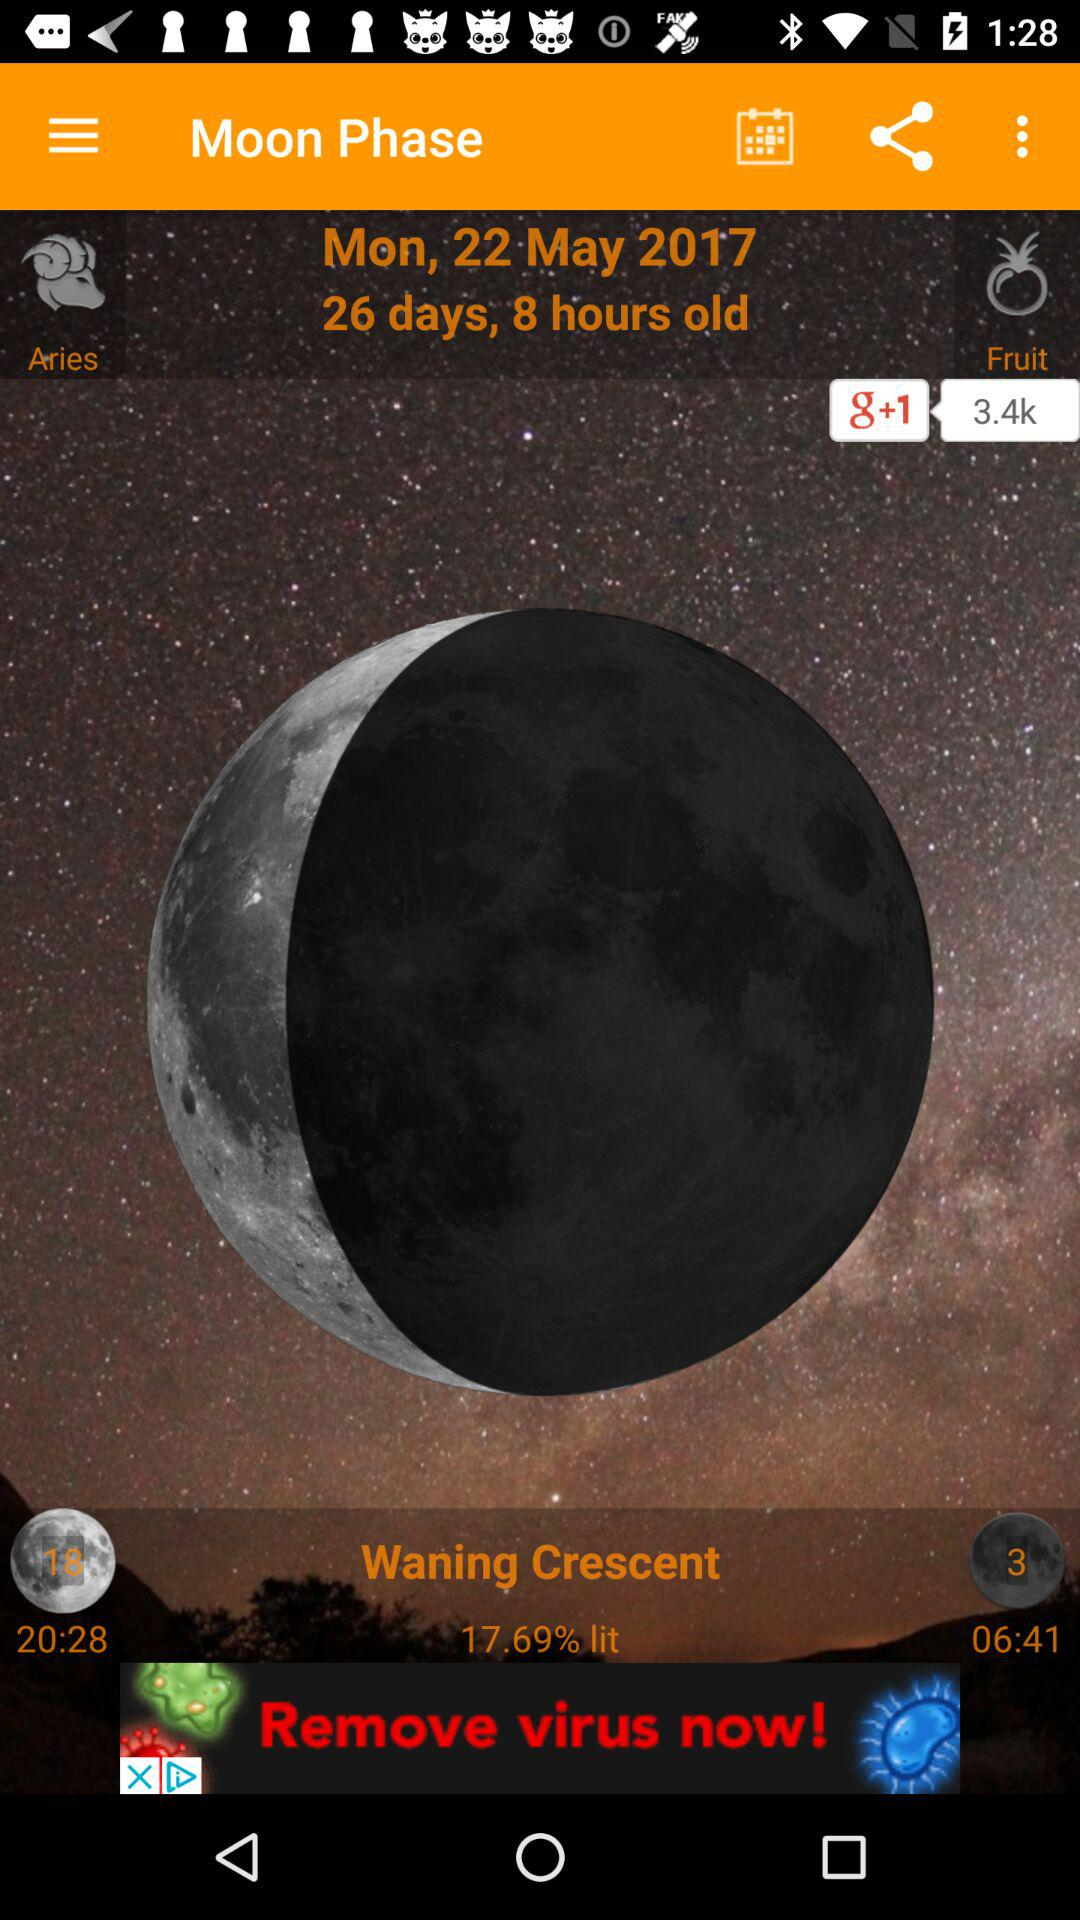How many days and hours old is the moon?
Answer the question using a single word or phrase. 26 days, 8 hours 